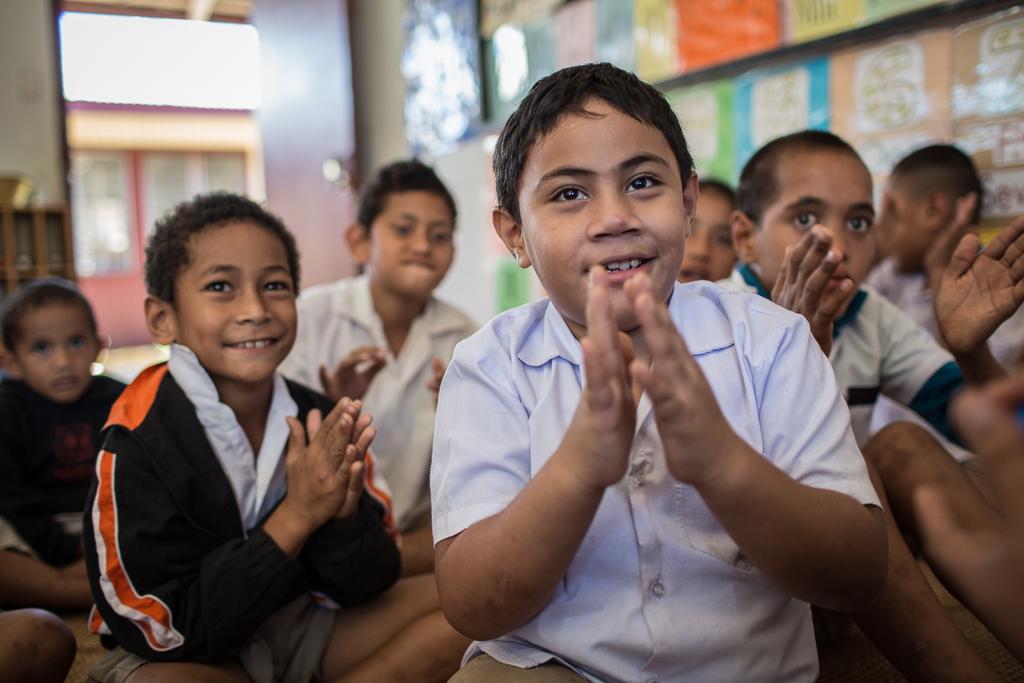Describe this image in one or two sentences. In this picture we can see a few kids from left to right. There are a few colorful objects on the wall on the right side. We can see a door, a door handle and a wooden object at the back. Background is blurry. 